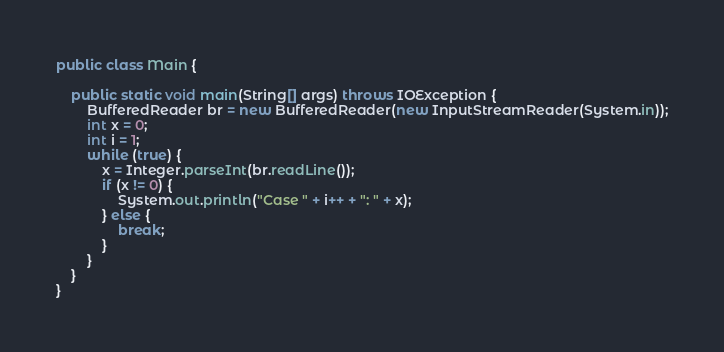<code> <loc_0><loc_0><loc_500><loc_500><_Java_>public class Main {

    public static void main(String[] args) throws IOException {
        BufferedReader br = new BufferedReader(new InputStreamReader(System.in));
        int x = 0;
        int i = 1;
        while (true) {
            x = Integer.parseInt(br.readLine());
            if (x != 0) {
                System.out.println("Case " + i++ + ": " + x);
            } else {
                break;
            }
        }
    }
}</code> 